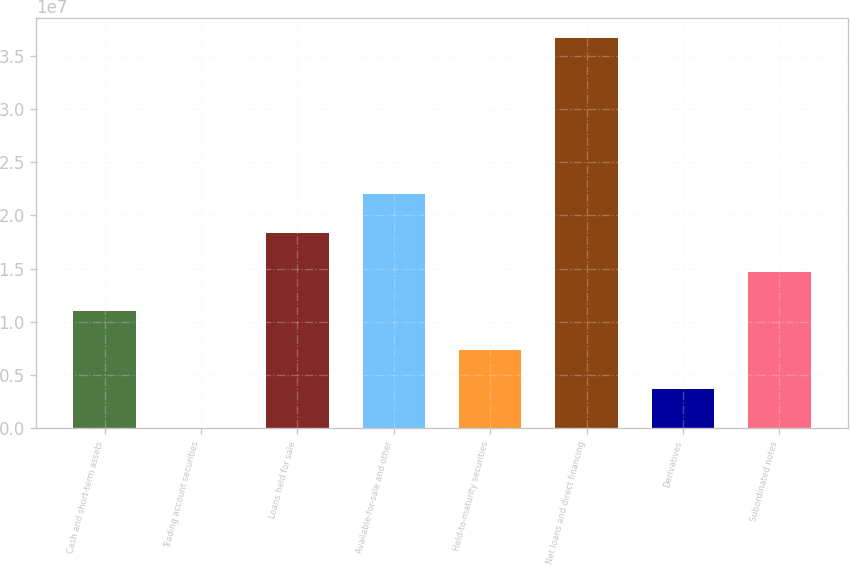Convert chart to OTSL. <chart><loc_0><loc_0><loc_500><loc_500><bar_chart><fcel>Cash and short-term assets<fcel>Trading account securities<fcel>Loans held for sale<fcel>Available-for-sale and other<fcel>Held-to-maturity securities<fcel>Net loans and direct financing<fcel>Derivatives<fcel>Subordinated notes<nl><fcel>1.10331e+07<fcel>45899<fcel>1.83579e+07<fcel>2.20203e+07<fcel>7.37068e+06<fcel>3.66698e+07<fcel>3.70829e+06<fcel>1.46955e+07<nl></chart> 